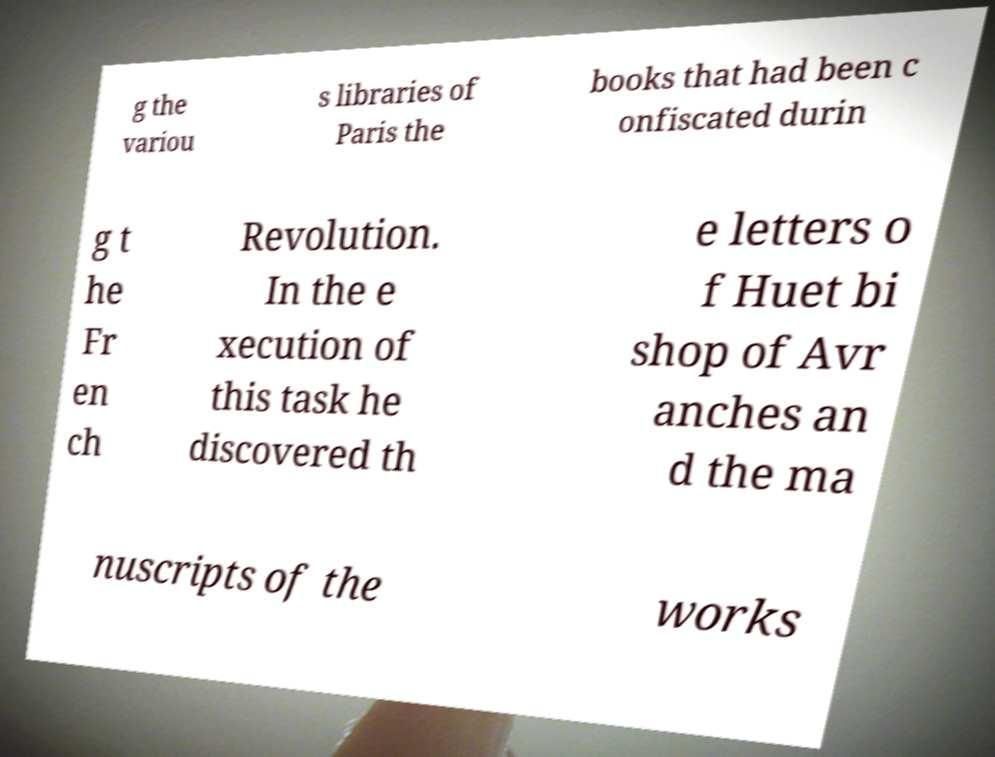What messages or text are displayed in this image? I need them in a readable, typed format. g the variou s libraries of Paris the books that had been c onfiscated durin g t he Fr en ch Revolution. In the e xecution of this task he discovered th e letters o f Huet bi shop of Avr anches an d the ma nuscripts of the works 